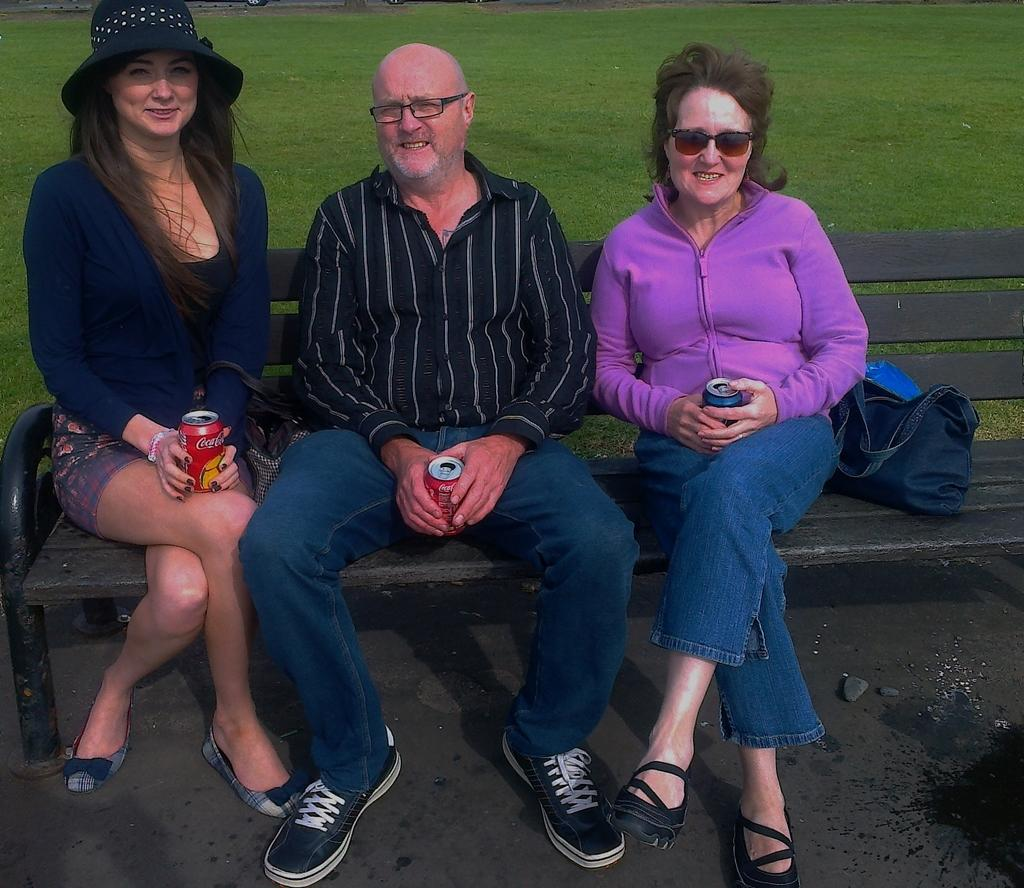What are the people in the image doing? The people in the image are sitting on a bench. What are the people holding in their hands? The people are holding tins. What is the facial expression of the people in the image? The people are smiling. What can be seen in the background of the image? There is grass visible in the background of the image. What else is present on the bench besides the people? There is a bag on the bench. How many kittens are playing with the box on the bench in the image? There are no kittens or boxes present in the image. What type of ants can be seen crawling on the people's legs in the image? There are no ants visible in the image. 